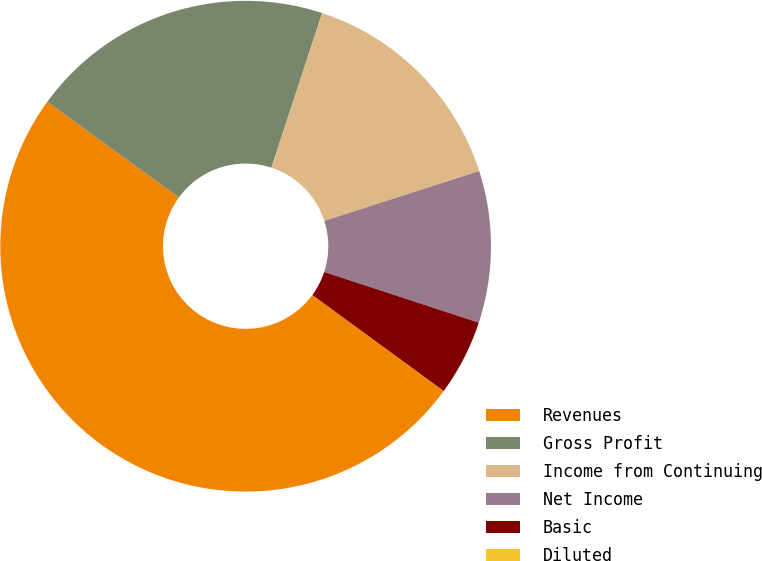Convert chart. <chart><loc_0><loc_0><loc_500><loc_500><pie_chart><fcel>Revenues<fcel>Gross Profit<fcel>Income from Continuing<fcel>Net Income<fcel>Basic<fcel>Diluted<nl><fcel>49.96%<fcel>20.03%<fcel>15.0%<fcel>10.0%<fcel>5.01%<fcel>0.01%<nl></chart> 